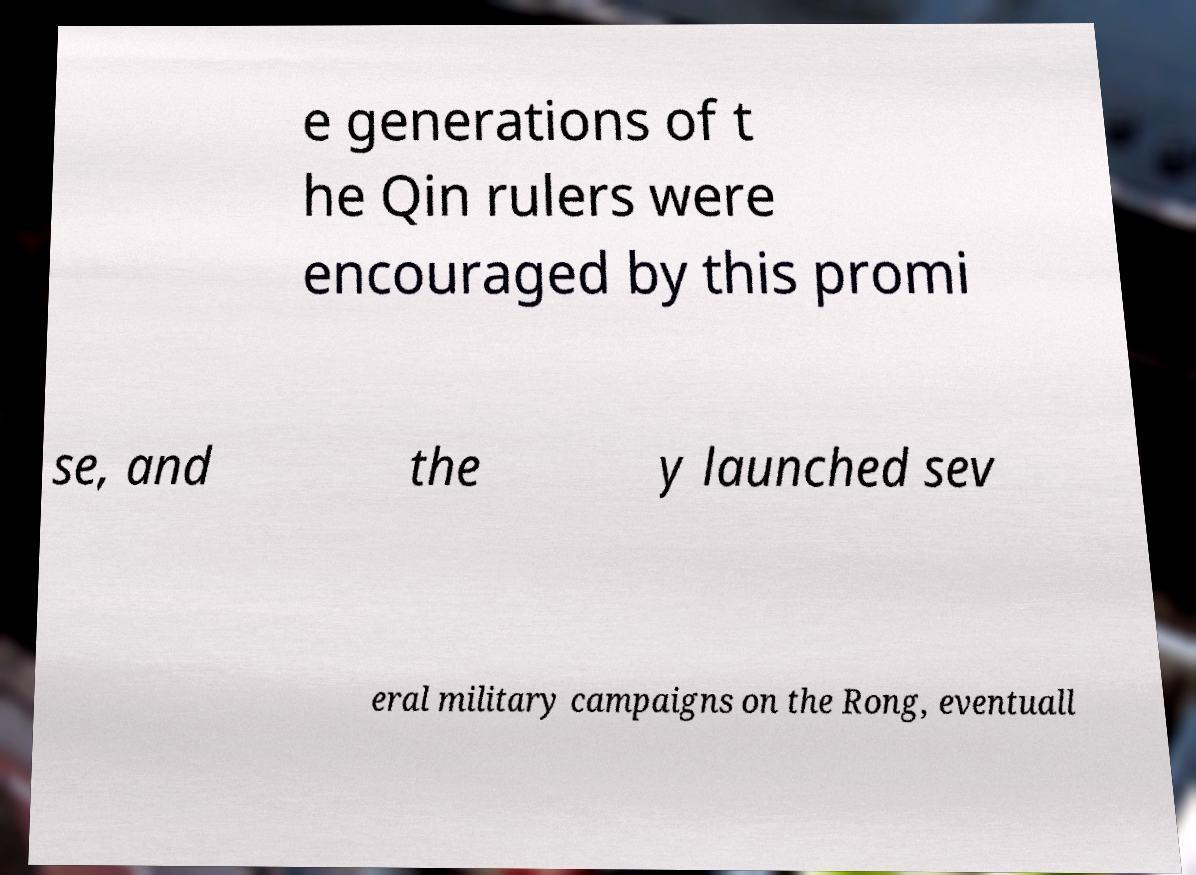Can you read and provide the text displayed in the image?This photo seems to have some interesting text. Can you extract and type it out for me? e generations of t he Qin rulers were encouraged by this promi se, and the y launched sev eral military campaigns on the Rong, eventuall 